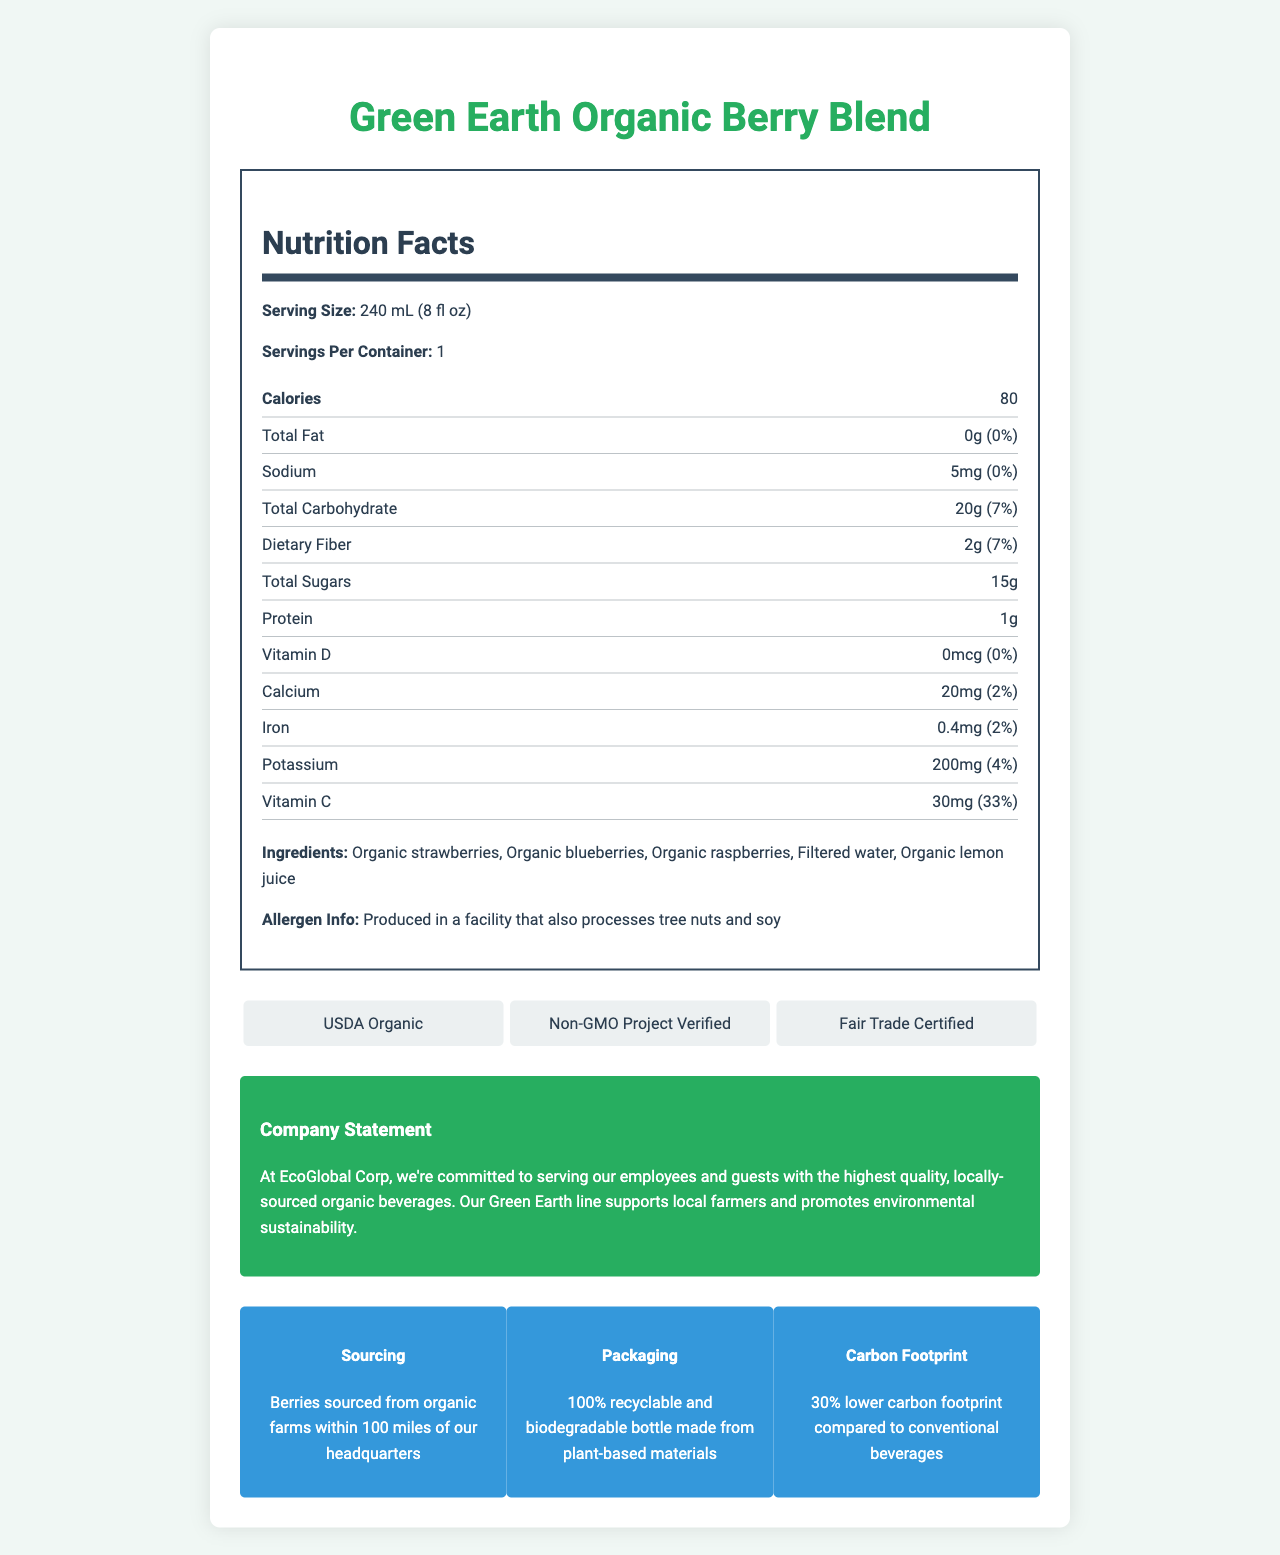what is the serving size? The serving size is explicitly stated at the top of the Nutrition Facts section.
Answer: 240 mL (8 fl oz) how many calories are in one serving? The number of calories per serving is clearly listed in the Nutrition Facts section.
Answer: 80 what is the total fat content per serving? The total fat content is specified right below the calorie information in the Nutrition Facts section.
Answer: 0g how much sodium does the beverage contain? The sodium content is listed in the Nutrition Facts under the "Sodium" label.
Answer: 5mg what is the amount of total carbohydrates per serving? The total carbohydrate content can be found within the Nutrition Facts section, clearly labeled.
Answer: 20g how much dietary fiber is present in the beverage? The dietary fiber content is listed under the "Dietary Fiber" section in the Nutrition Facts.
Answer: 2g how much added sugar does the beverage contain? The added sugars section specifies that it contains 0g of added sugars.
Answer: 0g which vitamin has the highest daily value percentage? A. Vitamin D B. Calcium C. Iron D. Vitamin C The Nutrition Facts section shows that Vitamin C has a daily value of 33%, which is higher than the listed percentages for Vitamin D, Calcium, or Iron.
Answer: D. Vitamin C what is the daily value percentage of iron in the beverage? The iron percentage is located in the Nutrition Facts under the "Iron" section.
Answer: 2% which of the following certifications does the beverage have? A. USDA Organic B. Fair Trade Certified C. Non-GMO Project Verified D. All of the above The certifications section lists USDA Organic, Non-GMO Project Verified, and Fair Trade Certified.
Answer: D. All of the above is the packaging recyclable? The eco-info section confirms that the packaging is 100% recyclable and biodegradable.
Answer: Yes which ingredient is listed first? The ingredients section lists organic strawberries as the first ingredient.
Answer: Organic strawberries what is the purpose of the company statement? The company statement is designed to convey EcoGlobal Corp's dedication to quality, local sourcing, and sustainability.
Answer: To express EcoGlobal Corp's commitment to serving high-quality, locally-sourced organic beverages and promoting environmental sustainability what is the allergen information for this beverage? The allergen information is found at the bottom of the ingredients list.
Answer: Produced in a facility that also processes tree nuts and soy describe the main idea of the document. The document combines detailed product-specific nutritional facts with information about the company's environmental and sourcing commitments, offering a comprehensive overview of the product's nutritional content and the company's values.
Answer: The document provides detailed nutritional information and certifications for Green Earth Organic Berry Blend, an organic beverage served at corporate events. It highlights the company's commitment to sustainability, local sourcing, and offers relevant allergen information and eco-friendly packaging details. does this beverage contain any protein? The Nutrition Facts section lists 1g of protein in the beverage.
Answer: Yes what is the net carbon footprint reduction of this beverage compared to conventional beverages? The eco-info section specifies that the beverage has a 30% lower carbon footprint compared to conventional beverages.
Answer: 30% lower what is the total sugar content in the beverage? The total sugars, including natural sources, are listed as 15g in the Nutrition Facts.
Answer: 15g is the source of the berries used in this beverage mentioned? The sourcing info states that the berries are sourced from organic farms within 100 miles of the headquarters.
Answer: Yes how much calcium does the beverage contain? The calcium content is listed under the "Calcium" section in the Nutrition Facts.
Answer: 20mg who is the primary supplier of the berries in the beverage? The document only states that the berries are sourced from organic farms within 100 miles of the headquarters but does not specify a primary supplier.
Answer: Not enough information 